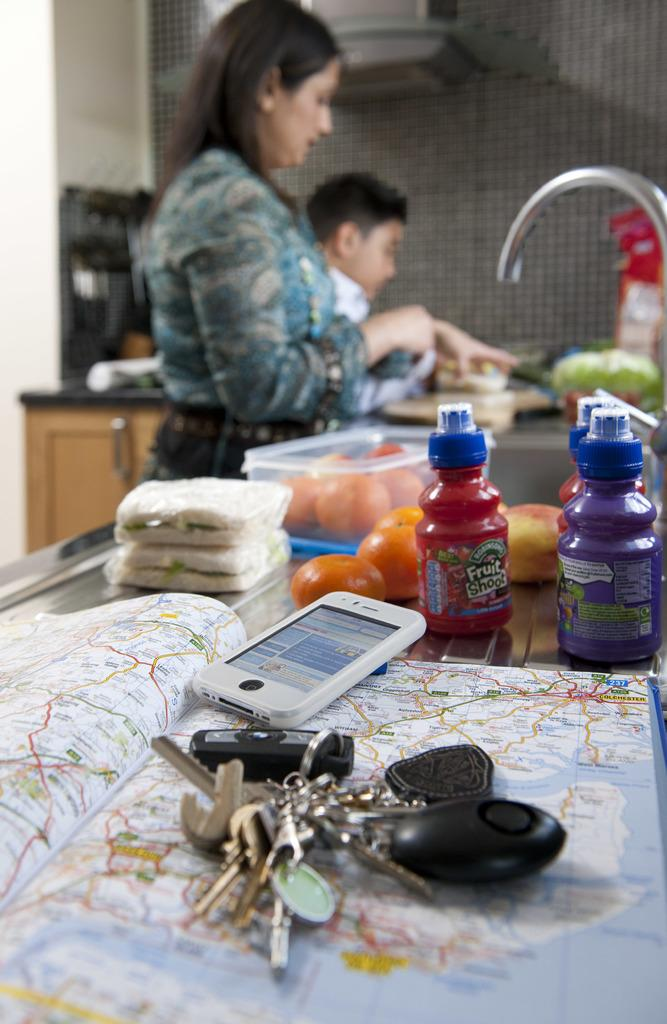Who is present in the image? There is a woman in the image. Can you describe the position of the boy in relation to the woman? There is a boy on the left side of the woman in the image. What electronic device can be seen in the image? There is a smartphone in the image. What other objects are present in the image? There are keys and a book in the image. What type of rose is the boy holding in the image? There is no rose present in the image; the boy is not holding anything. 